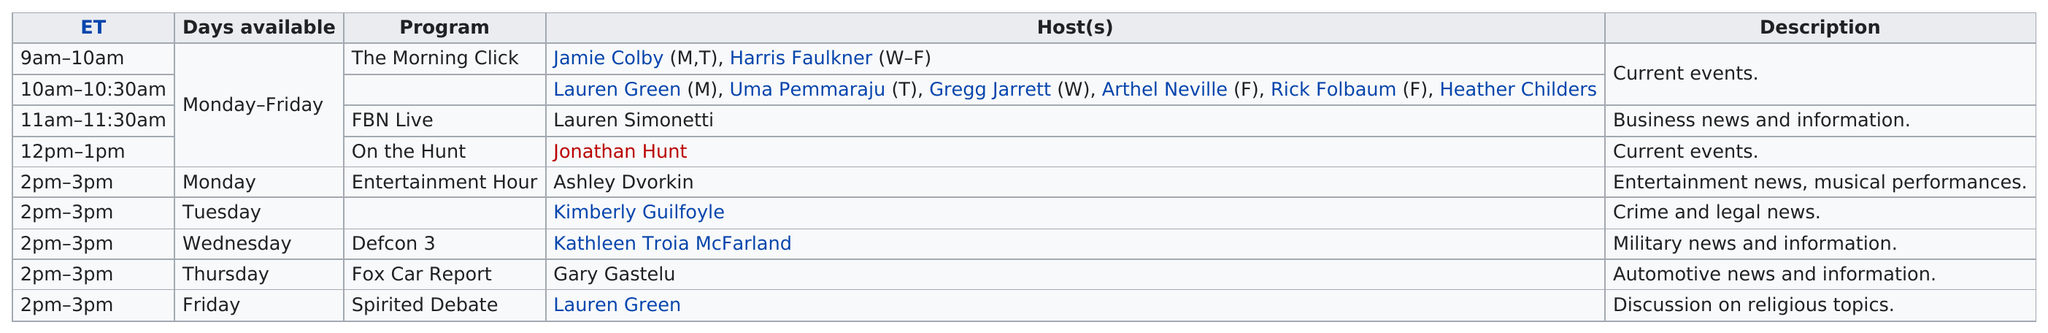Identify some key points in this picture. The FNB Live broadcast is available for 5 days each week. The first show to be played on Monday mornings is titled "The Morning Click. On Mondays, immediately following "On the Hunt," a show called "Entertainment Hour" airs. Defcon 3 lasts for one hour. The Fox Car Report program is only available on Thursdays. 